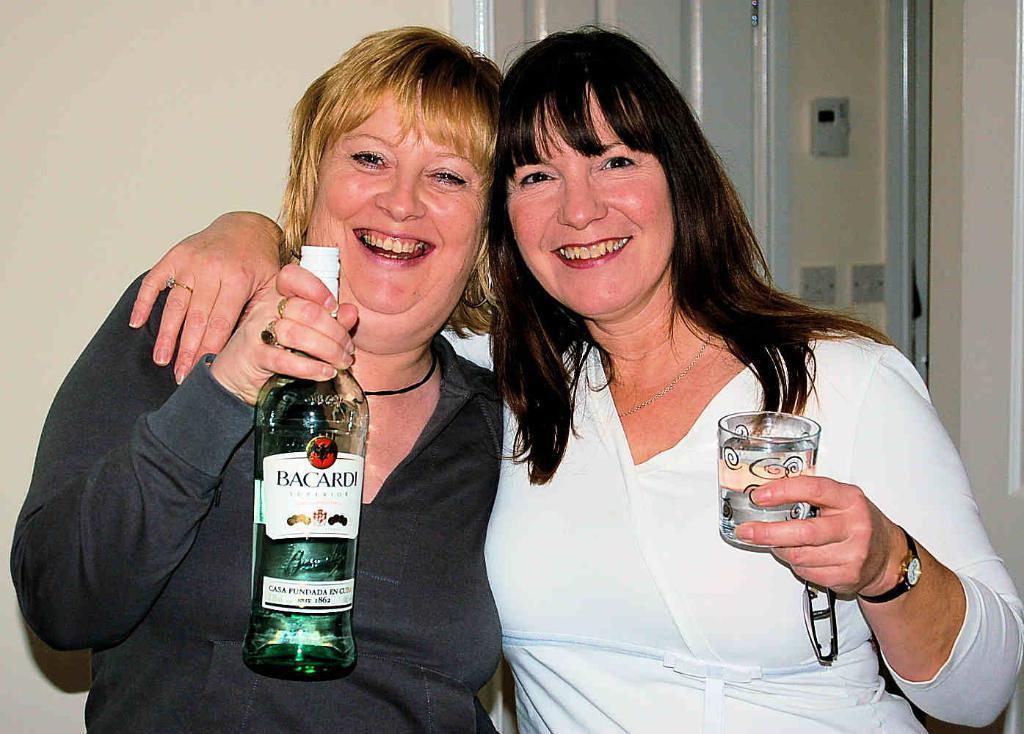Please provide a concise description of this image. This picture shows a two woman smiling and holding a wine bottle and a glass in their hands. In the background there is a wall. 